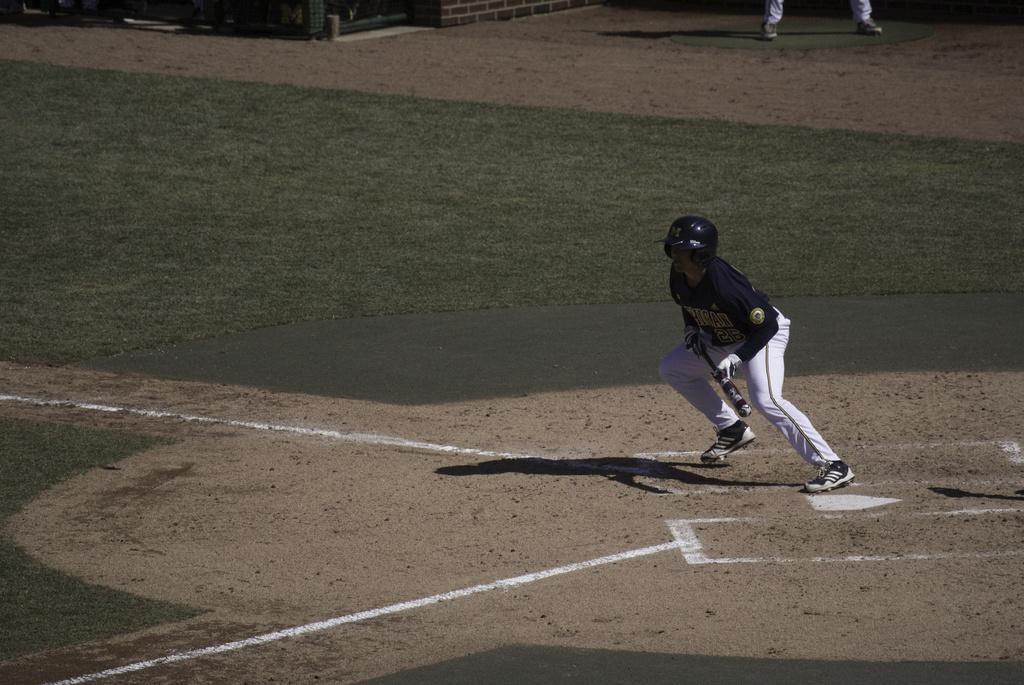How would you summarize this image in a sentence or two? In the front of the image a person wore a helmet and holding a bat. In the background of the image there is a ground carpet, legs of a person and objects.   